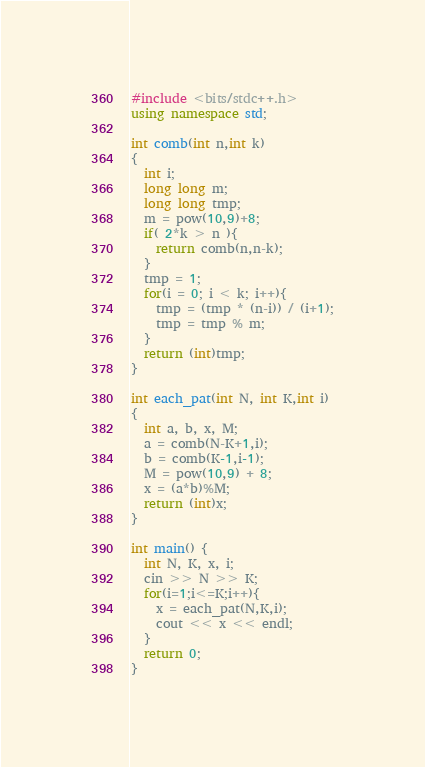Convert code to text. <code><loc_0><loc_0><loc_500><loc_500><_C++_>#include <bits/stdc++.h>
using namespace std;

int comb(int n,int k)
{
  int i;
  long long m;
  long long tmp;
  m = pow(10,9)+8;
  if( 2*k > n ){
    return comb(n,n-k);
  }
  tmp = 1;
  for(i = 0; i < k; i++){
    tmp = (tmp * (n-i)) / (i+1);
    tmp = tmp % m;
  }
  return (int)tmp;
}

int each_pat(int N, int K,int i)
{
  int a, b, x, M;
  a = comb(N-K+1,i);
  b = comb(K-1,i-1);
  M = pow(10,9) + 8;
  x = (a*b)%M;
  return (int)x;
}

int main() {
  int N, K, x, i;
  cin >> N >> K;
  for(i=1;i<=K;i++){
    x = each_pat(N,K,i);
    cout << x << endl;
  }
  return 0;
}
</code> 